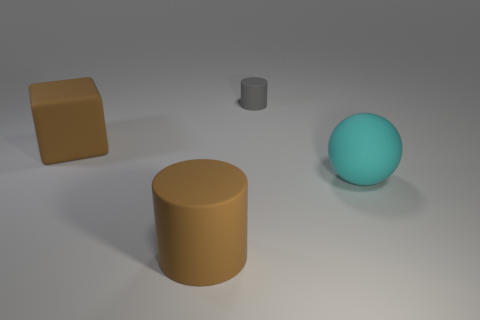The brown matte object that is the same size as the brown cylinder is what shape?
Keep it short and to the point. Cube. What size is the gray cylinder?
Give a very brief answer. Small. What number of cyan rubber spheres are the same size as the brown rubber cube?
Make the answer very short. 1. There is a rubber object that is in front of the sphere; is it the same size as the rubber cylinder behind the cyan object?
Keep it short and to the point. No. There is a brown rubber cylinder; is it the same size as the cyan matte object in front of the big rubber cube?
Offer a very short reply. Yes. How many other things are made of the same material as the large brown cylinder?
Your answer should be very brief. 3. Are there the same number of big matte cubes right of the large ball and small brown cylinders?
Offer a very short reply. Yes. What is the color of the matte cylinder on the left side of the tiny rubber cylinder?
Offer a terse response. Brown. Is there any other thing that is the same shape as the big cyan thing?
Your answer should be very brief. No. How big is the brown thing that is on the right side of the large matte thing behind the cyan sphere?
Your answer should be very brief. Large. 